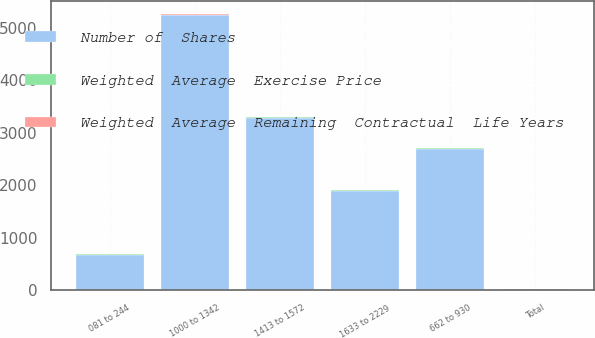Convert chart. <chart><loc_0><loc_0><loc_500><loc_500><stacked_bar_chart><ecel><fcel>081 to 244<fcel>662 to 930<fcel>1000 to 1342<fcel>1413 to 1572<fcel>1633 to 2229<fcel>Total<nl><fcel>Number of  Shares<fcel>679<fcel>2692<fcel>5231<fcel>3278<fcel>1895<fcel>12.39<nl><fcel>Weighted  Average  Remaining  Contractual  Life Years<fcel>1<fcel>6<fcel>6.8<fcel>7.1<fcel>6.2<fcel>6.3<nl><fcel>Weighted  Average  Exercise Price<fcel>2.43<fcel>7.16<fcel>13.21<fcel>14.71<fcel>17.15<fcel>12.39<nl></chart> 